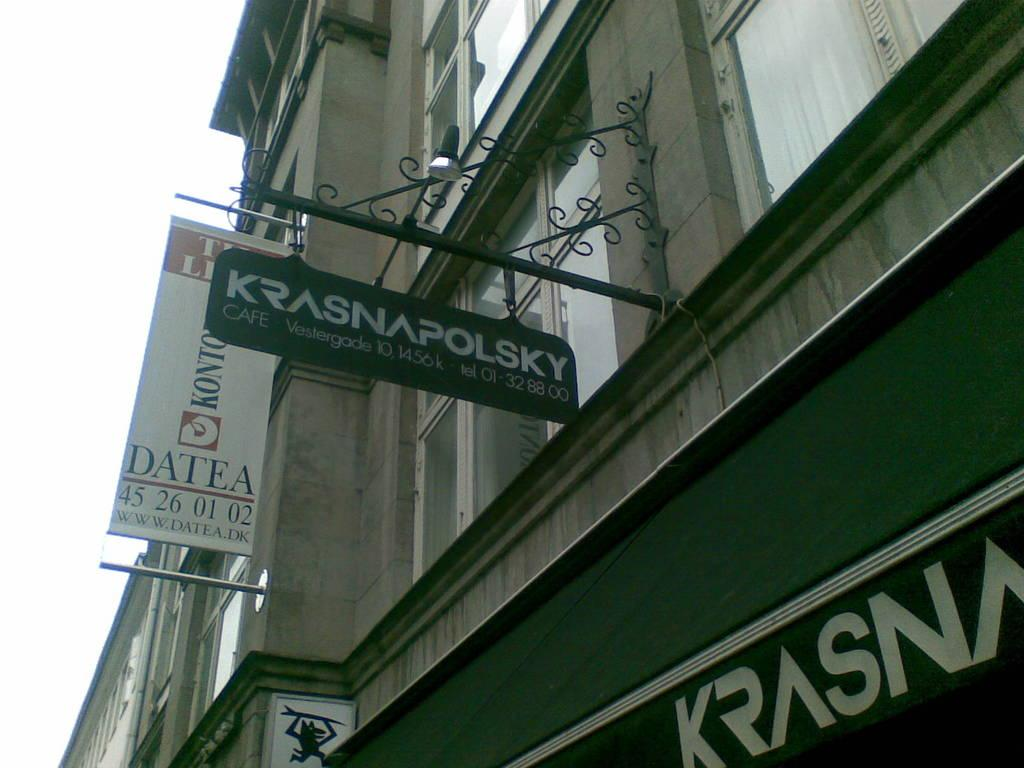What type of advertising is present in the image? There are hoardings and a banner in the image. What is the appearance of the building in the image? The building has glass windows. What can be seen in the background of the image? The sky is visible in the background of the image. How many grapes are hanging from the banner in the image? There are no grapes present in the image; the banner is attached to a building. 